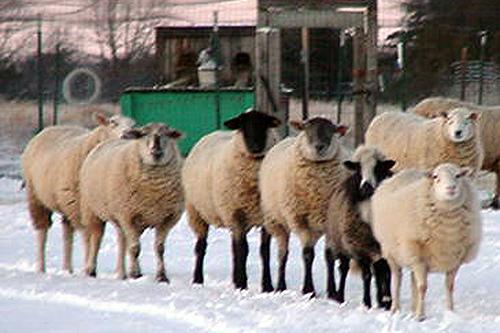How many sheep are there?
Concise answer only. 8. How many sheep is this?
Keep it brief. 8. What are the sheep standing in?
Answer briefly. Snow. 